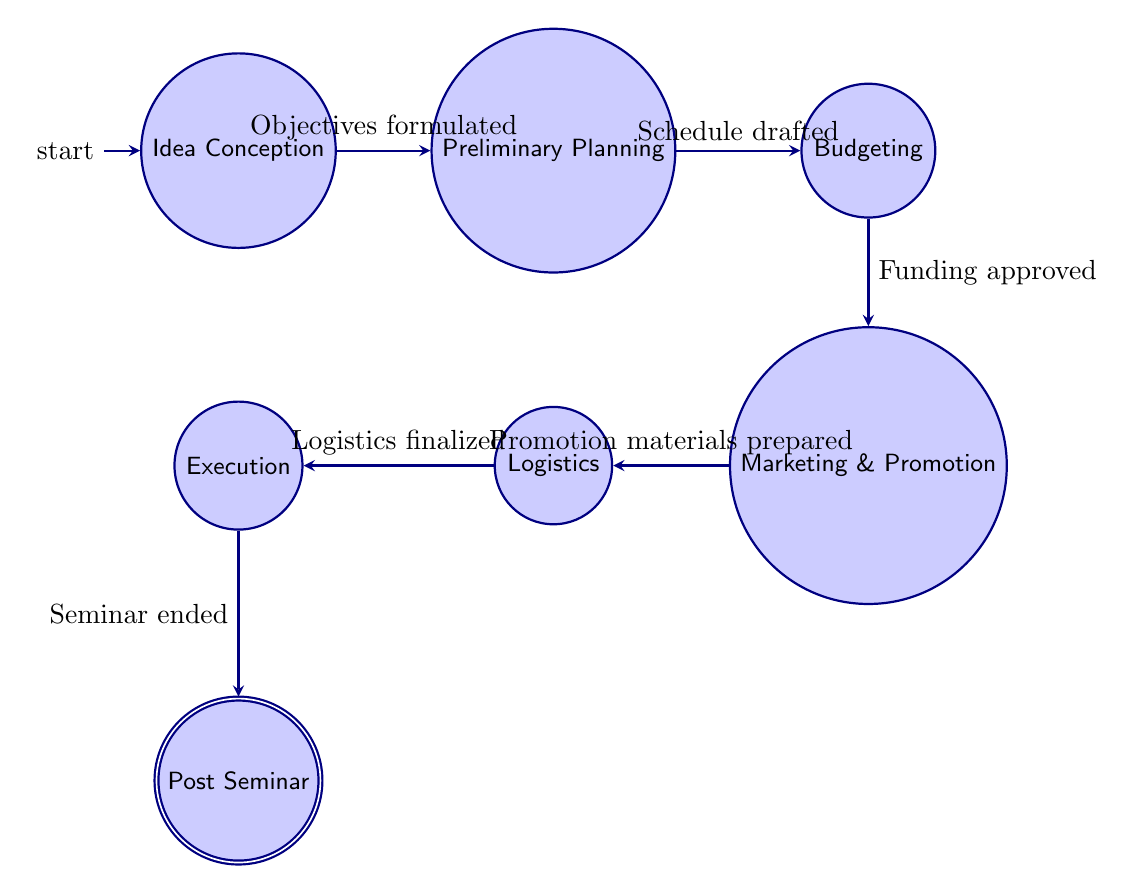What is the starting state of the diagram? The diagram indicates that the initial state is "Idea Conception," which is labeled as such in the diagram.
Answer: Idea Conception How many nodes are present in the diagram? Counting the states in the diagram, there are a total of 7 nodes: Idea Conception, Preliminary Planning, Budgeting, Marketing & Promotion, Logistics, Execution, and Post Seminar.
Answer: 7 What is the last state in the sequence? The final state indicated in the diagram is "Post Seminar," where the flow of the process concludes as marked by the accepting state.
Answer: Post Seminar What action comes after "Budgeting"? From the transitions detailed in the diagram, after "Budgeting," the next state is "Marketing & Promotion." This indicates the progression in the seminar organization process.
Answer: Marketing & Promotion What condition must be met to transition from "Logistics" to "Execution"? The transition from "Logistics" to "Execution" requires the condition "Logistics finalized" to be satisfied, as specified in the diagram's transitions.
Answer: Logistics finalized How many transitions are there in total? By reviewing the transitions listed in the diagram, there are 6 connections (or edges) that dictate how the states move from one to the next throughout the organizing process of the seminar.
Answer: 6 Which state requires the condition "Funding approved" to transition? The transition that requires "Funding approved" is between the "Budgeting" state and the "Marketing & Promotion" state, indicating that funding approval is crucial before moving to marketing efforts.
Answer: Budgeting In which state would you find the action "Draft tentative schedule"? The action "Draft tentative schedule" can be found under the "Preliminary Planning" state, which focuses on early steps in organizing the seminar.
Answer: Preliminary Planning What is the primary theme of the diagram? The primary theme of the diagram revolves around organizing a student seminar, specifically focusing on 19th-century European political movements as indicated by the context.
Answer: Organizing seminar 